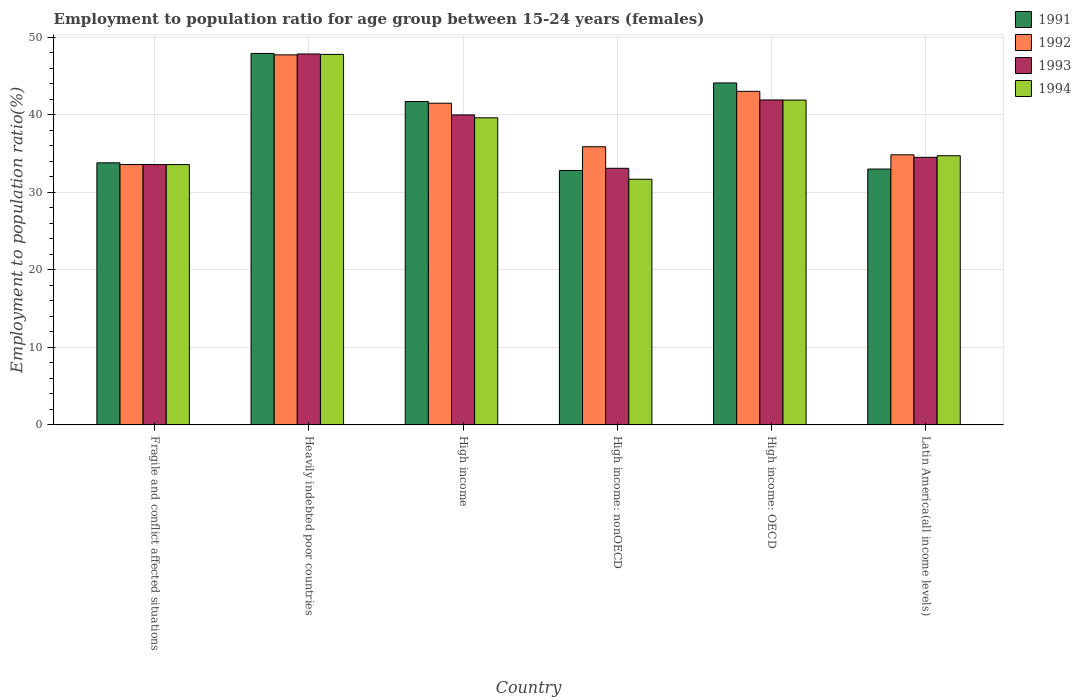How many different coloured bars are there?
Provide a succinct answer. 4. How many groups of bars are there?
Your answer should be very brief. 6. How many bars are there on the 5th tick from the left?
Ensure brevity in your answer.  4. What is the label of the 5th group of bars from the left?
Offer a terse response. High income: OECD. In how many cases, is the number of bars for a given country not equal to the number of legend labels?
Offer a very short reply. 0. What is the employment to population ratio in 1992 in High income: OECD?
Your answer should be very brief. 43.03. Across all countries, what is the maximum employment to population ratio in 1991?
Provide a succinct answer. 47.92. Across all countries, what is the minimum employment to population ratio in 1991?
Your response must be concise. 32.83. In which country was the employment to population ratio in 1993 maximum?
Provide a succinct answer. Heavily indebted poor countries. In which country was the employment to population ratio in 1991 minimum?
Keep it short and to the point. High income: nonOECD. What is the total employment to population ratio in 1994 in the graph?
Ensure brevity in your answer.  229.32. What is the difference between the employment to population ratio in 1991 in High income: OECD and that in High income: nonOECD?
Your answer should be very brief. 11.29. What is the difference between the employment to population ratio in 1992 in Latin America(all income levels) and the employment to population ratio in 1993 in High income: OECD?
Provide a succinct answer. -7.08. What is the average employment to population ratio in 1994 per country?
Keep it short and to the point. 38.22. What is the difference between the employment to population ratio of/in 1994 and employment to population ratio of/in 1993 in High income: OECD?
Provide a succinct answer. -0.02. In how many countries, is the employment to population ratio in 1991 greater than 46 %?
Your answer should be compact. 1. What is the ratio of the employment to population ratio in 1992 in Heavily indebted poor countries to that in High income?
Offer a terse response. 1.15. What is the difference between the highest and the second highest employment to population ratio in 1993?
Ensure brevity in your answer.  1.93. What is the difference between the highest and the lowest employment to population ratio in 1993?
Provide a short and direct response. 14.75. In how many countries, is the employment to population ratio in 1994 greater than the average employment to population ratio in 1994 taken over all countries?
Provide a succinct answer. 3. Is the sum of the employment to population ratio in 1993 in High income and High income: OECD greater than the maximum employment to population ratio in 1992 across all countries?
Give a very brief answer. Yes. Is it the case that in every country, the sum of the employment to population ratio in 1992 and employment to population ratio in 1994 is greater than the sum of employment to population ratio in 1993 and employment to population ratio in 1991?
Keep it short and to the point. No. What does the 3rd bar from the left in High income represents?
Keep it short and to the point. 1993. What does the 2nd bar from the right in Fragile and conflict affected situations represents?
Give a very brief answer. 1993. How many bars are there?
Give a very brief answer. 24. What is the difference between two consecutive major ticks on the Y-axis?
Your answer should be compact. 10. Does the graph contain grids?
Keep it short and to the point. Yes. What is the title of the graph?
Ensure brevity in your answer.  Employment to population ratio for age group between 15-24 years (females). Does "1981" appear as one of the legend labels in the graph?
Provide a succinct answer. No. What is the label or title of the X-axis?
Keep it short and to the point. Country. What is the label or title of the Y-axis?
Your answer should be compact. Employment to population ratio(%). What is the Employment to population ratio(%) of 1991 in Fragile and conflict affected situations?
Provide a short and direct response. 33.81. What is the Employment to population ratio(%) in 1992 in Fragile and conflict affected situations?
Your answer should be very brief. 33.59. What is the Employment to population ratio(%) in 1993 in Fragile and conflict affected situations?
Offer a terse response. 33.59. What is the Employment to population ratio(%) in 1994 in Fragile and conflict affected situations?
Make the answer very short. 33.59. What is the Employment to population ratio(%) in 1991 in Heavily indebted poor countries?
Your answer should be compact. 47.92. What is the Employment to population ratio(%) of 1992 in Heavily indebted poor countries?
Your response must be concise. 47.74. What is the Employment to population ratio(%) of 1993 in Heavily indebted poor countries?
Offer a terse response. 47.85. What is the Employment to population ratio(%) in 1994 in Heavily indebted poor countries?
Make the answer very short. 47.8. What is the Employment to population ratio(%) in 1991 in High income?
Provide a succinct answer. 41.72. What is the Employment to population ratio(%) in 1992 in High income?
Your response must be concise. 41.5. What is the Employment to population ratio(%) of 1993 in High income?
Provide a short and direct response. 39.99. What is the Employment to population ratio(%) in 1994 in High income?
Make the answer very short. 39.62. What is the Employment to population ratio(%) of 1991 in High income: nonOECD?
Your response must be concise. 32.83. What is the Employment to population ratio(%) of 1992 in High income: nonOECD?
Your answer should be very brief. 35.89. What is the Employment to population ratio(%) in 1993 in High income: nonOECD?
Provide a succinct answer. 33.1. What is the Employment to population ratio(%) in 1994 in High income: nonOECD?
Make the answer very short. 31.69. What is the Employment to population ratio(%) in 1991 in High income: OECD?
Make the answer very short. 44.12. What is the Employment to population ratio(%) in 1992 in High income: OECD?
Provide a succinct answer. 43.03. What is the Employment to population ratio(%) of 1993 in High income: OECD?
Your answer should be compact. 41.92. What is the Employment to population ratio(%) of 1994 in High income: OECD?
Offer a very short reply. 41.9. What is the Employment to population ratio(%) in 1991 in Latin America(all income levels)?
Keep it short and to the point. 33.01. What is the Employment to population ratio(%) in 1992 in Latin America(all income levels)?
Give a very brief answer. 34.84. What is the Employment to population ratio(%) of 1993 in Latin America(all income levels)?
Your answer should be very brief. 34.52. What is the Employment to population ratio(%) in 1994 in Latin America(all income levels)?
Your response must be concise. 34.73. Across all countries, what is the maximum Employment to population ratio(%) in 1991?
Provide a short and direct response. 47.92. Across all countries, what is the maximum Employment to population ratio(%) in 1992?
Provide a succinct answer. 47.74. Across all countries, what is the maximum Employment to population ratio(%) in 1993?
Make the answer very short. 47.85. Across all countries, what is the maximum Employment to population ratio(%) in 1994?
Your answer should be very brief. 47.8. Across all countries, what is the minimum Employment to population ratio(%) of 1991?
Your answer should be compact. 32.83. Across all countries, what is the minimum Employment to population ratio(%) in 1992?
Keep it short and to the point. 33.59. Across all countries, what is the minimum Employment to population ratio(%) of 1993?
Your response must be concise. 33.1. Across all countries, what is the minimum Employment to population ratio(%) in 1994?
Provide a short and direct response. 31.69. What is the total Employment to population ratio(%) in 1991 in the graph?
Offer a terse response. 233.39. What is the total Employment to population ratio(%) of 1992 in the graph?
Keep it short and to the point. 236.59. What is the total Employment to population ratio(%) in 1993 in the graph?
Make the answer very short. 230.97. What is the total Employment to population ratio(%) in 1994 in the graph?
Your answer should be very brief. 229.32. What is the difference between the Employment to population ratio(%) of 1991 in Fragile and conflict affected situations and that in Heavily indebted poor countries?
Provide a short and direct response. -14.11. What is the difference between the Employment to population ratio(%) of 1992 in Fragile and conflict affected situations and that in Heavily indebted poor countries?
Your answer should be very brief. -14.15. What is the difference between the Employment to population ratio(%) in 1993 in Fragile and conflict affected situations and that in Heavily indebted poor countries?
Provide a short and direct response. -14.26. What is the difference between the Employment to population ratio(%) in 1994 in Fragile and conflict affected situations and that in Heavily indebted poor countries?
Provide a short and direct response. -14.21. What is the difference between the Employment to population ratio(%) in 1991 in Fragile and conflict affected situations and that in High income?
Offer a very short reply. -7.91. What is the difference between the Employment to population ratio(%) in 1992 in Fragile and conflict affected situations and that in High income?
Keep it short and to the point. -7.91. What is the difference between the Employment to population ratio(%) in 1993 in Fragile and conflict affected situations and that in High income?
Your answer should be compact. -6.4. What is the difference between the Employment to population ratio(%) of 1994 in Fragile and conflict affected situations and that in High income?
Your answer should be compact. -6.03. What is the difference between the Employment to population ratio(%) in 1991 in Fragile and conflict affected situations and that in High income: nonOECD?
Provide a succinct answer. 0.98. What is the difference between the Employment to population ratio(%) in 1992 in Fragile and conflict affected situations and that in High income: nonOECD?
Give a very brief answer. -2.3. What is the difference between the Employment to population ratio(%) in 1993 in Fragile and conflict affected situations and that in High income: nonOECD?
Provide a short and direct response. 0.48. What is the difference between the Employment to population ratio(%) in 1994 in Fragile and conflict affected situations and that in High income: nonOECD?
Your answer should be compact. 1.89. What is the difference between the Employment to population ratio(%) in 1991 in Fragile and conflict affected situations and that in High income: OECD?
Offer a very short reply. -10.31. What is the difference between the Employment to population ratio(%) in 1992 in Fragile and conflict affected situations and that in High income: OECD?
Give a very brief answer. -9.44. What is the difference between the Employment to population ratio(%) of 1993 in Fragile and conflict affected situations and that in High income: OECD?
Your response must be concise. -8.33. What is the difference between the Employment to population ratio(%) of 1994 in Fragile and conflict affected situations and that in High income: OECD?
Offer a very short reply. -8.32. What is the difference between the Employment to population ratio(%) in 1991 in Fragile and conflict affected situations and that in Latin America(all income levels)?
Offer a terse response. 0.8. What is the difference between the Employment to population ratio(%) in 1992 in Fragile and conflict affected situations and that in Latin America(all income levels)?
Offer a terse response. -1.25. What is the difference between the Employment to population ratio(%) of 1993 in Fragile and conflict affected situations and that in Latin America(all income levels)?
Offer a very short reply. -0.93. What is the difference between the Employment to population ratio(%) in 1994 in Fragile and conflict affected situations and that in Latin America(all income levels)?
Your answer should be compact. -1.14. What is the difference between the Employment to population ratio(%) in 1991 in Heavily indebted poor countries and that in High income?
Provide a short and direct response. 6.2. What is the difference between the Employment to population ratio(%) of 1992 in Heavily indebted poor countries and that in High income?
Your response must be concise. 6.24. What is the difference between the Employment to population ratio(%) of 1993 in Heavily indebted poor countries and that in High income?
Keep it short and to the point. 7.86. What is the difference between the Employment to population ratio(%) in 1994 in Heavily indebted poor countries and that in High income?
Offer a terse response. 8.18. What is the difference between the Employment to population ratio(%) in 1991 in Heavily indebted poor countries and that in High income: nonOECD?
Your response must be concise. 15.1. What is the difference between the Employment to population ratio(%) in 1992 in Heavily indebted poor countries and that in High income: nonOECD?
Provide a short and direct response. 11.85. What is the difference between the Employment to population ratio(%) of 1993 in Heavily indebted poor countries and that in High income: nonOECD?
Make the answer very short. 14.75. What is the difference between the Employment to population ratio(%) in 1994 in Heavily indebted poor countries and that in High income: nonOECD?
Provide a short and direct response. 16.1. What is the difference between the Employment to population ratio(%) of 1991 in Heavily indebted poor countries and that in High income: OECD?
Keep it short and to the point. 3.8. What is the difference between the Employment to population ratio(%) in 1992 in Heavily indebted poor countries and that in High income: OECD?
Keep it short and to the point. 4.71. What is the difference between the Employment to population ratio(%) in 1993 in Heavily indebted poor countries and that in High income: OECD?
Your response must be concise. 5.93. What is the difference between the Employment to population ratio(%) of 1994 in Heavily indebted poor countries and that in High income: OECD?
Give a very brief answer. 5.89. What is the difference between the Employment to population ratio(%) in 1991 in Heavily indebted poor countries and that in Latin America(all income levels)?
Keep it short and to the point. 14.91. What is the difference between the Employment to population ratio(%) in 1992 in Heavily indebted poor countries and that in Latin America(all income levels)?
Your answer should be compact. 12.9. What is the difference between the Employment to population ratio(%) of 1993 in Heavily indebted poor countries and that in Latin America(all income levels)?
Keep it short and to the point. 13.33. What is the difference between the Employment to population ratio(%) in 1994 in Heavily indebted poor countries and that in Latin America(all income levels)?
Make the answer very short. 13.07. What is the difference between the Employment to population ratio(%) in 1991 in High income and that in High income: nonOECD?
Provide a short and direct response. 8.89. What is the difference between the Employment to population ratio(%) in 1992 in High income and that in High income: nonOECD?
Provide a short and direct response. 5.61. What is the difference between the Employment to population ratio(%) of 1993 in High income and that in High income: nonOECD?
Offer a very short reply. 6.89. What is the difference between the Employment to population ratio(%) in 1994 in High income and that in High income: nonOECD?
Your answer should be compact. 7.92. What is the difference between the Employment to population ratio(%) in 1991 in High income and that in High income: OECD?
Provide a short and direct response. -2.4. What is the difference between the Employment to population ratio(%) in 1992 in High income and that in High income: OECD?
Your answer should be very brief. -1.53. What is the difference between the Employment to population ratio(%) in 1993 in High income and that in High income: OECD?
Ensure brevity in your answer.  -1.93. What is the difference between the Employment to population ratio(%) in 1994 in High income and that in High income: OECD?
Provide a succinct answer. -2.28. What is the difference between the Employment to population ratio(%) of 1991 in High income and that in Latin America(all income levels)?
Provide a short and direct response. 8.71. What is the difference between the Employment to population ratio(%) in 1992 in High income and that in Latin America(all income levels)?
Give a very brief answer. 6.66. What is the difference between the Employment to population ratio(%) in 1993 in High income and that in Latin America(all income levels)?
Keep it short and to the point. 5.47. What is the difference between the Employment to population ratio(%) in 1994 in High income and that in Latin America(all income levels)?
Offer a terse response. 4.89. What is the difference between the Employment to population ratio(%) of 1991 in High income: nonOECD and that in High income: OECD?
Offer a very short reply. -11.29. What is the difference between the Employment to population ratio(%) in 1992 in High income: nonOECD and that in High income: OECD?
Offer a very short reply. -7.15. What is the difference between the Employment to population ratio(%) in 1993 in High income: nonOECD and that in High income: OECD?
Your answer should be compact. -8.82. What is the difference between the Employment to population ratio(%) of 1994 in High income: nonOECD and that in High income: OECD?
Provide a succinct answer. -10.21. What is the difference between the Employment to population ratio(%) of 1991 in High income: nonOECD and that in Latin America(all income levels)?
Offer a terse response. -0.18. What is the difference between the Employment to population ratio(%) in 1992 in High income: nonOECD and that in Latin America(all income levels)?
Provide a succinct answer. 1.04. What is the difference between the Employment to population ratio(%) of 1993 in High income: nonOECD and that in Latin America(all income levels)?
Provide a succinct answer. -1.42. What is the difference between the Employment to population ratio(%) in 1994 in High income: nonOECD and that in Latin America(all income levels)?
Offer a very short reply. -3.03. What is the difference between the Employment to population ratio(%) of 1991 in High income: OECD and that in Latin America(all income levels)?
Keep it short and to the point. 11.11. What is the difference between the Employment to population ratio(%) in 1992 in High income: OECD and that in Latin America(all income levels)?
Ensure brevity in your answer.  8.19. What is the difference between the Employment to population ratio(%) in 1993 in High income: OECD and that in Latin America(all income levels)?
Your response must be concise. 7.4. What is the difference between the Employment to population ratio(%) of 1994 in High income: OECD and that in Latin America(all income levels)?
Your response must be concise. 7.18. What is the difference between the Employment to population ratio(%) in 1991 in Fragile and conflict affected situations and the Employment to population ratio(%) in 1992 in Heavily indebted poor countries?
Make the answer very short. -13.93. What is the difference between the Employment to population ratio(%) of 1991 in Fragile and conflict affected situations and the Employment to population ratio(%) of 1993 in Heavily indebted poor countries?
Offer a terse response. -14.04. What is the difference between the Employment to population ratio(%) in 1991 in Fragile and conflict affected situations and the Employment to population ratio(%) in 1994 in Heavily indebted poor countries?
Ensure brevity in your answer.  -13.99. What is the difference between the Employment to population ratio(%) of 1992 in Fragile and conflict affected situations and the Employment to population ratio(%) of 1993 in Heavily indebted poor countries?
Your answer should be compact. -14.26. What is the difference between the Employment to population ratio(%) in 1992 in Fragile and conflict affected situations and the Employment to population ratio(%) in 1994 in Heavily indebted poor countries?
Provide a short and direct response. -14.21. What is the difference between the Employment to population ratio(%) of 1993 in Fragile and conflict affected situations and the Employment to population ratio(%) of 1994 in Heavily indebted poor countries?
Provide a short and direct response. -14.21. What is the difference between the Employment to population ratio(%) in 1991 in Fragile and conflict affected situations and the Employment to population ratio(%) in 1992 in High income?
Provide a succinct answer. -7.69. What is the difference between the Employment to population ratio(%) in 1991 in Fragile and conflict affected situations and the Employment to population ratio(%) in 1993 in High income?
Keep it short and to the point. -6.18. What is the difference between the Employment to population ratio(%) in 1991 in Fragile and conflict affected situations and the Employment to population ratio(%) in 1994 in High income?
Provide a succinct answer. -5.81. What is the difference between the Employment to population ratio(%) of 1992 in Fragile and conflict affected situations and the Employment to population ratio(%) of 1993 in High income?
Your answer should be compact. -6.4. What is the difference between the Employment to population ratio(%) of 1992 in Fragile and conflict affected situations and the Employment to population ratio(%) of 1994 in High income?
Offer a terse response. -6.03. What is the difference between the Employment to population ratio(%) in 1993 in Fragile and conflict affected situations and the Employment to population ratio(%) in 1994 in High income?
Keep it short and to the point. -6.03. What is the difference between the Employment to population ratio(%) of 1991 in Fragile and conflict affected situations and the Employment to population ratio(%) of 1992 in High income: nonOECD?
Offer a terse response. -2.08. What is the difference between the Employment to population ratio(%) in 1991 in Fragile and conflict affected situations and the Employment to population ratio(%) in 1993 in High income: nonOECD?
Offer a terse response. 0.71. What is the difference between the Employment to population ratio(%) of 1991 in Fragile and conflict affected situations and the Employment to population ratio(%) of 1994 in High income: nonOECD?
Provide a short and direct response. 2.12. What is the difference between the Employment to population ratio(%) of 1992 in Fragile and conflict affected situations and the Employment to population ratio(%) of 1993 in High income: nonOECD?
Offer a terse response. 0.49. What is the difference between the Employment to population ratio(%) of 1992 in Fragile and conflict affected situations and the Employment to population ratio(%) of 1994 in High income: nonOECD?
Your answer should be compact. 1.9. What is the difference between the Employment to population ratio(%) in 1993 in Fragile and conflict affected situations and the Employment to population ratio(%) in 1994 in High income: nonOECD?
Ensure brevity in your answer.  1.89. What is the difference between the Employment to population ratio(%) in 1991 in Fragile and conflict affected situations and the Employment to population ratio(%) in 1992 in High income: OECD?
Give a very brief answer. -9.22. What is the difference between the Employment to population ratio(%) in 1991 in Fragile and conflict affected situations and the Employment to population ratio(%) in 1993 in High income: OECD?
Keep it short and to the point. -8.11. What is the difference between the Employment to population ratio(%) of 1991 in Fragile and conflict affected situations and the Employment to population ratio(%) of 1994 in High income: OECD?
Give a very brief answer. -8.09. What is the difference between the Employment to population ratio(%) of 1992 in Fragile and conflict affected situations and the Employment to population ratio(%) of 1993 in High income: OECD?
Give a very brief answer. -8.33. What is the difference between the Employment to population ratio(%) in 1992 in Fragile and conflict affected situations and the Employment to population ratio(%) in 1994 in High income: OECD?
Offer a terse response. -8.31. What is the difference between the Employment to population ratio(%) of 1993 in Fragile and conflict affected situations and the Employment to population ratio(%) of 1994 in High income: OECD?
Make the answer very short. -8.31. What is the difference between the Employment to population ratio(%) of 1991 in Fragile and conflict affected situations and the Employment to population ratio(%) of 1992 in Latin America(all income levels)?
Offer a very short reply. -1.03. What is the difference between the Employment to population ratio(%) of 1991 in Fragile and conflict affected situations and the Employment to population ratio(%) of 1993 in Latin America(all income levels)?
Keep it short and to the point. -0.71. What is the difference between the Employment to population ratio(%) of 1991 in Fragile and conflict affected situations and the Employment to population ratio(%) of 1994 in Latin America(all income levels)?
Offer a very short reply. -0.92. What is the difference between the Employment to population ratio(%) of 1992 in Fragile and conflict affected situations and the Employment to population ratio(%) of 1993 in Latin America(all income levels)?
Provide a succinct answer. -0.93. What is the difference between the Employment to population ratio(%) of 1992 in Fragile and conflict affected situations and the Employment to population ratio(%) of 1994 in Latin America(all income levels)?
Provide a succinct answer. -1.14. What is the difference between the Employment to population ratio(%) of 1993 in Fragile and conflict affected situations and the Employment to population ratio(%) of 1994 in Latin America(all income levels)?
Your answer should be compact. -1.14. What is the difference between the Employment to population ratio(%) in 1991 in Heavily indebted poor countries and the Employment to population ratio(%) in 1992 in High income?
Keep it short and to the point. 6.42. What is the difference between the Employment to population ratio(%) in 1991 in Heavily indebted poor countries and the Employment to population ratio(%) in 1993 in High income?
Give a very brief answer. 7.93. What is the difference between the Employment to population ratio(%) of 1991 in Heavily indebted poor countries and the Employment to population ratio(%) of 1994 in High income?
Keep it short and to the point. 8.3. What is the difference between the Employment to population ratio(%) of 1992 in Heavily indebted poor countries and the Employment to population ratio(%) of 1993 in High income?
Offer a terse response. 7.75. What is the difference between the Employment to population ratio(%) of 1992 in Heavily indebted poor countries and the Employment to population ratio(%) of 1994 in High income?
Provide a succinct answer. 8.12. What is the difference between the Employment to population ratio(%) of 1993 in Heavily indebted poor countries and the Employment to population ratio(%) of 1994 in High income?
Your answer should be compact. 8.23. What is the difference between the Employment to population ratio(%) in 1991 in Heavily indebted poor countries and the Employment to population ratio(%) in 1992 in High income: nonOECD?
Keep it short and to the point. 12.03. What is the difference between the Employment to population ratio(%) in 1991 in Heavily indebted poor countries and the Employment to population ratio(%) in 1993 in High income: nonOECD?
Provide a short and direct response. 14.82. What is the difference between the Employment to population ratio(%) of 1991 in Heavily indebted poor countries and the Employment to population ratio(%) of 1994 in High income: nonOECD?
Offer a terse response. 16.23. What is the difference between the Employment to population ratio(%) in 1992 in Heavily indebted poor countries and the Employment to population ratio(%) in 1993 in High income: nonOECD?
Keep it short and to the point. 14.64. What is the difference between the Employment to population ratio(%) of 1992 in Heavily indebted poor countries and the Employment to population ratio(%) of 1994 in High income: nonOECD?
Your answer should be compact. 16.05. What is the difference between the Employment to population ratio(%) of 1993 in Heavily indebted poor countries and the Employment to population ratio(%) of 1994 in High income: nonOECD?
Keep it short and to the point. 16.16. What is the difference between the Employment to population ratio(%) of 1991 in Heavily indebted poor countries and the Employment to population ratio(%) of 1992 in High income: OECD?
Provide a short and direct response. 4.89. What is the difference between the Employment to population ratio(%) of 1991 in Heavily indebted poor countries and the Employment to population ratio(%) of 1993 in High income: OECD?
Your answer should be compact. 6. What is the difference between the Employment to population ratio(%) in 1991 in Heavily indebted poor countries and the Employment to population ratio(%) in 1994 in High income: OECD?
Your response must be concise. 6.02. What is the difference between the Employment to population ratio(%) of 1992 in Heavily indebted poor countries and the Employment to population ratio(%) of 1993 in High income: OECD?
Your answer should be compact. 5.82. What is the difference between the Employment to population ratio(%) of 1992 in Heavily indebted poor countries and the Employment to population ratio(%) of 1994 in High income: OECD?
Ensure brevity in your answer.  5.84. What is the difference between the Employment to population ratio(%) of 1993 in Heavily indebted poor countries and the Employment to population ratio(%) of 1994 in High income: OECD?
Ensure brevity in your answer.  5.95. What is the difference between the Employment to population ratio(%) of 1991 in Heavily indebted poor countries and the Employment to population ratio(%) of 1992 in Latin America(all income levels)?
Your answer should be compact. 13.08. What is the difference between the Employment to population ratio(%) of 1991 in Heavily indebted poor countries and the Employment to population ratio(%) of 1993 in Latin America(all income levels)?
Provide a short and direct response. 13.4. What is the difference between the Employment to population ratio(%) in 1991 in Heavily indebted poor countries and the Employment to population ratio(%) in 1994 in Latin America(all income levels)?
Your response must be concise. 13.19. What is the difference between the Employment to population ratio(%) in 1992 in Heavily indebted poor countries and the Employment to population ratio(%) in 1993 in Latin America(all income levels)?
Make the answer very short. 13.22. What is the difference between the Employment to population ratio(%) of 1992 in Heavily indebted poor countries and the Employment to population ratio(%) of 1994 in Latin America(all income levels)?
Give a very brief answer. 13.01. What is the difference between the Employment to population ratio(%) in 1993 in Heavily indebted poor countries and the Employment to population ratio(%) in 1994 in Latin America(all income levels)?
Give a very brief answer. 13.13. What is the difference between the Employment to population ratio(%) of 1991 in High income and the Employment to population ratio(%) of 1992 in High income: nonOECD?
Keep it short and to the point. 5.83. What is the difference between the Employment to population ratio(%) in 1991 in High income and the Employment to population ratio(%) in 1993 in High income: nonOECD?
Ensure brevity in your answer.  8.61. What is the difference between the Employment to population ratio(%) of 1991 in High income and the Employment to population ratio(%) of 1994 in High income: nonOECD?
Your answer should be very brief. 10.02. What is the difference between the Employment to population ratio(%) of 1992 in High income and the Employment to population ratio(%) of 1993 in High income: nonOECD?
Provide a short and direct response. 8.4. What is the difference between the Employment to population ratio(%) of 1992 in High income and the Employment to population ratio(%) of 1994 in High income: nonOECD?
Make the answer very short. 9.81. What is the difference between the Employment to population ratio(%) of 1993 in High income and the Employment to population ratio(%) of 1994 in High income: nonOECD?
Your answer should be very brief. 8.3. What is the difference between the Employment to population ratio(%) of 1991 in High income and the Employment to population ratio(%) of 1992 in High income: OECD?
Provide a short and direct response. -1.32. What is the difference between the Employment to population ratio(%) of 1991 in High income and the Employment to population ratio(%) of 1993 in High income: OECD?
Ensure brevity in your answer.  -0.21. What is the difference between the Employment to population ratio(%) of 1991 in High income and the Employment to population ratio(%) of 1994 in High income: OECD?
Your response must be concise. -0.19. What is the difference between the Employment to population ratio(%) of 1992 in High income and the Employment to population ratio(%) of 1993 in High income: OECD?
Provide a succinct answer. -0.42. What is the difference between the Employment to population ratio(%) of 1992 in High income and the Employment to population ratio(%) of 1994 in High income: OECD?
Your answer should be very brief. -0.4. What is the difference between the Employment to population ratio(%) in 1993 in High income and the Employment to population ratio(%) in 1994 in High income: OECD?
Provide a succinct answer. -1.91. What is the difference between the Employment to population ratio(%) of 1991 in High income and the Employment to population ratio(%) of 1992 in Latin America(all income levels)?
Make the answer very short. 6.87. What is the difference between the Employment to population ratio(%) in 1991 in High income and the Employment to population ratio(%) in 1993 in Latin America(all income levels)?
Ensure brevity in your answer.  7.2. What is the difference between the Employment to population ratio(%) in 1991 in High income and the Employment to population ratio(%) in 1994 in Latin America(all income levels)?
Ensure brevity in your answer.  6.99. What is the difference between the Employment to population ratio(%) in 1992 in High income and the Employment to population ratio(%) in 1993 in Latin America(all income levels)?
Your response must be concise. 6.98. What is the difference between the Employment to population ratio(%) of 1992 in High income and the Employment to population ratio(%) of 1994 in Latin America(all income levels)?
Ensure brevity in your answer.  6.77. What is the difference between the Employment to population ratio(%) in 1993 in High income and the Employment to population ratio(%) in 1994 in Latin America(all income levels)?
Provide a succinct answer. 5.26. What is the difference between the Employment to population ratio(%) of 1991 in High income: nonOECD and the Employment to population ratio(%) of 1992 in High income: OECD?
Provide a short and direct response. -10.21. What is the difference between the Employment to population ratio(%) in 1991 in High income: nonOECD and the Employment to population ratio(%) in 1993 in High income: OECD?
Give a very brief answer. -9.1. What is the difference between the Employment to population ratio(%) in 1991 in High income: nonOECD and the Employment to population ratio(%) in 1994 in High income: OECD?
Your answer should be compact. -9.08. What is the difference between the Employment to population ratio(%) of 1992 in High income: nonOECD and the Employment to population ratio(%) of 1993 in High income: OECD?
Ensure brevity in your answer.  -6.04. What is the difference between the Employment to population ratio(%) of 1992 in High income: nonOECD and the Employment to population ratio(%) of 1994 in High income: OECD?
Provide a succinct answer. -6.02. What is the difference between the Employment to population ratio(%) in 1993 in High income: nonOECD and the Employment to population ratio(%) in 1994 in High income: OECD?
Offer a very short reply. -8.8. What is the difference between the Employment to population ratio(%) in 1991 in High income: nonOECD and the Employment to population ratio(%) in 1992 in Latin America(all income levels)?
Offer a very short reply. -2.02. What is the difference between the Employment to population ratio(%) of 1991 in High income: nonOECD and the Employment to population ratio(%) of 1993 in Latin America(all income levels)?
Provide a short and direct response. -1.69. What is the difference between the Employment to population ratio(%) in 1991 in High income: nonOECD and the Employment to population ratio(%) in 1994 in Latin America(all income levels)?
Ensure brevity in your answer.  -1.9. What is the difference between the Employment to population ratio(%) of 1992 in High income: nonOECD and the Employment to population ratio(%) of 1993 in Latin America(all income levels)?
Offer a very short reply. 1.37. What is the difference between the Employment to population ratio(%) in 1992 in High income: nonOECD and the Employment to population ratio(%) in 1994 in Latin America(all income levels)?
Keep it short and to the point. 1.16. What is the difference between the Employment to population ratio(%) in 1993 in High income: nonOECD and the Employment to population ratio(%) in 1994 in Latin America(all income levels)?
Provide a succinct answer. -1.62. What is the difference between the Employment to population ratio(%) of 1991 in High income: OECD and the Employment to population ratio(%) of 1992 in Latin America(all income levels)?
Offer a very short reply. 9.27. What is the difference between the Employment to population ratio(%) in 1991 in High income: OECD and the Employment to population ratio(%) in 1993 in Latin America(all income levels)?
Make the answer very short. 9.6. What is the difference between the Employment to population ratio(%) of 1991 in High income: OECD and the Employment to population ratio(%) of 1994 in Latin America(all income levels)?
Ensure brevity in your answer.  9.39. What is the difference between the Employment to population ratio(%) of 1992 in High income: OECD and the Employment to population ratio(%) of 1993 in Latin America(all income levels)?
Offer a very short reply. 8.51. What is the difference between the Employment to population ratio(%) of 1992 in High income: OECD and the Employment to population ratio(%) of 1994 in Latin America(all income levels)?
Your response must be concise. 8.31. What is the difference between the Employment to population ratio(%) of 1993 in High income: OECD and the Employment to population ratio(%) of 1994 in Latin America(all income levels)?
Offer a terse response. 7.2. What is the average Employment to population ratio(%) in 1991 per country?
Ensure brevity in your answer.  38.9. What is the average Employment to population ratio(%) of 1992 per country?
Make the answer very short. 39.43. What is the average Employment to population ratio(%) in 1993 per country?
Give a very brief answer. 38.5. What is the average Employment to population ratio(%) in 1994 per country?
Keep it short and to the point. 38.22. What is the difference between the Employment to population ratio(%) of 1991 and Employment to population ratio(%) of 1992 in Fragile and conflict affected situations?
Your response must be concise. 0.22. What is the difference between the Employment to population ratio(%) of 1991 and Employment to population ratio(%) of 1993 in Fragile and conflict affected situations?
Keep it short and to the point. 0.22. What is the difference between the Employment to population ratio(%) of 1991 and Employment to population ratio(%) of 1994 in Fragile and conflict affected situations?
Keep it short and to the point. 0.22. What is the difference between the Employment to population ratio(%) of 1992 and Employment to population ratio(%) of 1993 in Fragile and conflict affected situations?
Your answer should be compact. 0. What is the difference between the Employment to population ratio(%) in 1992 and Employment to population ratio(%) in 1994 in Fragile and conflict affected situations?
Offer a terse response. 0.01. What is the difference between the Employment to population ratio(%) of 1993 and Employment to population ratio(%) of 1994 in Fragile and conflict affected situations?
Provide a succinct answer. 0. What is the difference between the Employment to population ratio(%) of 1991 and Employment to population ratio(%) of 1992 in Heavily indebted poor countries?
Your response must be concise. 0.18. What is the difference between the Employment to population ratio(%) in 1991 and Employment to population ratio(%) in 1993 in Heavily indebted poor countries?
Offer a terse response. 0.07. What is the difference between the Employment to population ratio(%) of 1991 and Employment to population ratio(%) of 1994 in Heavily indebted poor countries?
Your response must be concise. 0.12. What is the difference between the Employment to population ratio(%) of 1992 and Employment to population ratio(%) of 1993 in Heavily indebted poor countries?
Provide a succinct answer. -0.11. What is the difference between the Employment to population ratio(%) in 1992 and Employment to population ratio(%) in 1994 in Heavily indebted poor countries?
Provide a short and direct response. -0.06. What is the difference between the Employment to population ratio(%) of 1993 and Employment to population ratio(%) of 1994 in Heavily indebted poor countries?
Offer a very short reply. 0.05. What is the difference between the Employment to population ratio(%) of 1991 and Employment to population ratio(%) of 1992 in High income?
Keep it short and to the point. 0.22. What is the difference between the Employment to population ratio(%) in 1991 and Employment to population ratio(%) in 1993 in High income?
Offer a terse response. 1.72. What is the difference between the Employment to population ratio(%) of 1991 and Employment to population ratio(%) of 1994 in High income?
Give a very brief answer. 2.1. What is the difference between the Employment to population ratio(%) of 1992 and Employment to population ratio(%) of 1993 in High income?
Your answer should be very brief. 1.51. What is the difference between the Employment to population ratio(%) in 1992 and Employment to population ratio(%) in 1994 in High income?
Give a very brief answer. 1.88. What is the difference between the Employment to population ratio(%) of 1993 and Employment to population ratio(%) of 1994 in High income?
Give a very brief answer. 0.37. What is the difference between the Employment to population ratio(%) of 1991 and Employment to population ratio(%) of 1992 in High income: nonOECD?
Give a very brief answer. -3.06. What is the difference between the Employment to population ratio(%) of 1991 and Employment to population ratio(%) of 1993 in High income: nonOECD?
Give a very brief answer. -0.28. What is the difference between the Employment to population ratio(%) of 1991 and Employment to population ratio(%) of 1994 in High income: nonOECD?
Your response must be concise. 1.13. What is the difference between the Employment to population ratio(%) in 1992 and Employment to population ratio(%) in 1993 in High income: nonOECD?
Give a very brief answer. 2.78. What is the difference between the Employment to population ratio(%) in 1992 and Employment to population ratio(%) in 1994 in High income: nonOECD?
Offer a very short reply. 4.19. What is the difference between the Employment to population ratio(%) of 1993 and Employment to population ratio(%) of 1994 in High income: nonOECD?
Give a very brief answer. 1.41. What is the difference between the Employment to population ratio(%) of 1991 and Employment to population ratio(%) of 1992 in High income: OECD?
Make the answer very short. 1.08. What is the difference between the Employment to population ratio(%) of 1991 and Employment to population ratio(%) of 1993 in High income: OECD?
Your answer should be compact. 2.2. What is the difference between the Employment to population ratio(%) in 1991 and Employment to population ratio(%) in 1994 in High income: OECD?
Provide a succinct answer. 2.21. What is the difference between the Employment to population ratio(%) of 1992 and Employment to population ratio(%) of 1993 in High income: OECD?
Ensure brevity in your answer.  1.11. What is the difference between the Employment to population ratio(%) in 1992 and Employment to population ratio(%) in 1994 in High income: OECD?
Your response must be concise. 1.13. What is the difference between the Employment to population ratio(%) of 1993 and Employment to population ratio(%) of 1994 in High income: OECD?
Offer a very short reply. 0.02. What is the difference between the Employment to population ratio(%) in 1991 and Employment to population ratio(%) in 1992 in Latin America(all income levels)?
Provide a short and direct response. -1.84. What is the difference between the Employment to population ratio(%) in 1991 and Employment to population ratio(%) in 1993 in Latin America(all income levels)?
Make the answer very short. -1.51. What is the difference between the Employment to population ratio(%) in 1991 and Employment to population ratio(%) in 1994 in Latin America(all income levels)?
Your answer should be very brief. -1.72. What is the difference between the Employment to population ratio(%) in 1992 and Employment to population ratio(%) in 1993 in Latin America(all income levels)?
Provide a succinct answer. 0.32. What is the difference between the Employment to population ratio(%) in 1992 and Employment to population ratio(%) in 1994 in Latin America(all income levels)?
Your answer should be very brief. 0.12. What is the difference between the Employment to population ratio(%) of 1993 and Employment to population ratio(%) of 1994 in Latin America(all income levels)?
Offer a very short reply. -0.21. What is the ratio of the Employment to population ratio(%) in 1991 in Fragile and conflict affected situations to that in Heavily indebted poor countries?
Offer a terse response. 0.71. What is the ratio of the Employment to population ratio(%) in 1992 in Fragile and conflict affected situations to that in Heavily indebted poor countries?
Ensure brevity in your answer.  0.7. What is the ratio of the Employment to population ratio(%) of 1993 in Fragile and conflict affected situations to that in Heavily indebted poor countries?
Keep it short and to the point. 0.7. What is the ratio of the Employment to population ratio(%) in 1994 in Fragile and conflict affected situations to that in Heavily indebted poor countries?
Your response must be concise. 0.7. What is the ratio of the Employment to population ratio(%) of 1991 in Fragile and conflict affected situations to that in High income?
Your response must be concise. 0.81. What is the ratio of the Employment to population ratio(%) in 1992 in Fragile and conflict affected situations to that in High income?
Provide a succinct answer. 0.81. What is the ratio of the Employment to population ratio(%) in 1993 in Fragile and conflict affected situations to that in High income?
Give a very brief answer. 0.84. What is the ratio of the Employment to population ratio(%) of 1994 in Fragile and conflict affected situations to that in High income?
Make the answer very short. 0.85. What is the ratio of the Employment to population ratio(%) of 1992 in Fragile and conflict affected situations to that in High income: nonOECD?
Your response must be concise. 0.94. What is the ratio of the Employment to population ratio(%) of 1993 in Fragile and conflict affected situations to that in High income: nonOECD?
Give a very brief answer. 1.01. What is the ratio of the Employment to population ratio(%) in 1994 in Fragile and conflict affected situations to that in High income: nonOECD?
Your answer should be compact. 1.06. What is the ratio of the Employment to population ratio(%) in 1991 in Fragile and conflict affected situations to that in High income: OECD?
Offer a terse response. 0.77. What is the ratio of the Employment to population ratio(%) in 1992 in Fragile and conflict affected situations to that in High income: OECD?
Give a very brief answer. 0.78. What is the ratio of the Employment to population ratio(%) in 1993 in Fragile and conflict affected situations to that in High income: OECD?
Provide a succinct answer. 0.8. What is the ratio of the Employment to population ratio(%) of 1994 in Fragile and conflict affected situations to that in High income: OECD?
Keep it short and to the point. 0.8. What is the ratio of the Employment to population ratio(%) of 1991 in Fragile and conflict affected situations to that in Latin America(all income levels)?
Ensure brevity in your answer.  1.02. What is the ratio of the Employment to population ratio(%) of 1992 in Fragile and conflict affected situations to that in Latin America(all income levels)?
Your response must be concise. 0.96. What is the ratio of the Employment to population ratio(%) in 1994 in Fragile and conflict affected situations to that in Latin America(all income levels)?
Provide a succinct answer. 0.97. What is the ratio of the Employment to population ratio(%) of 1991 in Heavily indebted poor countries to that in High income?
Offer a very short reply. 1.15. What is the ratio of the Employment to population ratio(%) in 1992 in Heavily indebted poor countries to that in High income?
Ensure brevity in your answer.  1.15. What is the ratio of the Employment to population ratio(%) of 1993 in Heavily indebted poor countries to that in High income?
Give a very brief answer. 1.2. What is the ratio of the Employment to population ratio(%) of 1994 in Heavily indebted poor countries to that in High income?
Your response must be concise. 1.21. What is the ratio of the Employment to population ratio(%) in 1991 in Heavily indebted poor countries to that in High income: nonOECD?
Your answer should be compact. 1.46. What is the ratio of the Employment to population ratio(%) of 1992 in Heavily indebted poor countries to that in High income: nonOECD?
Ensure brevity in your answer.  1.33. What is the ratio of the Employment to population ratio(%) of 1993 in Heavily indebted poor countries to that in High income: nonOECD?
Give a very brief answer. 1.45. What is the ratio of the Employment to population ratio(%) of 1994 in Heavily indebted poor countries to that in High income: nonOECD?
Provide a succinct answer. 1.51. What is the ratio of the Employment to population ratio(%) of 1991 in Heavily indebted poor countries to that in High income: OECD?
Your answer should be compact. 1.09. What is the ratio of the Employment to population ratio(%) in 1992 in Heavily indebted poor countries to that in High income: OECD?
Offer a terse response. 1.11. What is the ratio of the Employment to population ratio(%) of 1993 in Heavily indebted poor countries to that in High income: OECD?
Ensure brevity in your answer.  1.14. What is the ratio of the Employment to population ratio(%) in 1994 in Heavily indebted poor countries to that in High income: OECD?
Your answer should be very brief. 1.14. What is the ratio of the Employment to population ratio(%) in 1991 in Heavily indebted poor countries to that in Latin America(all income levels)?
Provide a succinct answer. 1.45. What is the ratio of the Employment to population ratio(%) in 1992 in Heavily indebted poor countries to that in Latin America(all income levels)?
Make the answer very short. 1.37. What is the ratio of the Employment to population ratio(%) of 1993 in Heavily indebted poor countries to that in Latin America(all income levels)?
Offer a terse response. 1.39. What is the ratio of the Employment to population ratio(%) of 1994 in Heavily indebted poor countries to that in Latin America(all income levels)?
Your answer should be very brief. 1.38. What is the ratio of the Employment to population ratio(%) in 1991 in High income to that in High income: nonOECD?
Ensure brevity in your answer.  1.27. What is the ratio of the Employment to population ratio(%) in 1992 in High income to that in High income: nonOECD?
Provide a short and direct response. 1.16. What is the ratio of the Employment to population ratio(%) in 1993 in High income to that in High income: nonOECD?
Give a very brief answer. 1.21. What is the ratio of the Employment to population ratio(%) of 1991 in High income to that in High income: OECD?
Provide a succinct answer. 0.95. What is the ratio of the Employment to population ratio(%) of 1992 in High income to that in High income: OECD?
Give a very brief answer. 0.96. What is the ratio of the Employment to population ratio(%) in 1993 in High income to that in High income: OECD?
Offer a terse response. 0.95. What is the ratio of the Employment to population ratio(%) of 1994 in High income to that in High income: OECD?
Your answer should be compact. 0.95. What is the ratio of the Employment to population ratio(%) of 1991 in High income to that in Latin America(all income levels)?
Keep it short and to the point. 1.26. What is the ratio of the Employment to population ratio(%) of 1992 in High income to that in Latin America(all income levels)?
Provide a short and direct response. 1.19. What is the ratio of the Employment to population ratio(%) in 1993 in High income to that in Latin America(all income levels)?
Offer a very short reply. 1.16. What is the ratio of the Employment to population ratio(%) of 1994 in High income to that in Latin America(all income levels)?
Your answer should be very brief. 1.14. What is the ratio of the Employment to population ratio(%) in 1991 in High income: nonOECD to that in High income: OECD?
Make the answer very short. 0.74. What is the ratio of the Employment to population ratio(%) of 1992 in High income: nonOECD to that in High income: OECD?
Your response must be concise. 0.83. What is the ratio of the Employment to population ratio(%) in 1993 in High income: nonOECD to that in High income: OECD?
Provide a succinct answer. 0.79. What is the ratio of the Employment to population ratio(%) in 1994 in High income: nonOECD to that in High income: OECD?
Your answer should be very brief. 0.76. What is the ratio of the Employment to population ratio(%) in 1991 in High income: nonOECD to that in Latin America(all income levels)?
Provide a succinct answer. 0.99. What is the ratio of the Employment to population ratio(%) of 1992 in High income: nonOECD to that in Latin America(all income levels)?
Offer a very short reply. 1.03. What is the ratio of the Employment to population ratio(%) of 1993 in High income: nonOECD to that in Latin America(all income levels)?
Offer a very short reply. 0.96. What is the ratio of the Employment to population ratio(%) of 1994 in High income: nonOECD to that in Latin America(all income levels)?
Keep it short and to the point. 0.91. What is the ratio of the Employment to population ratio(%) of 1991 in High income: OECD to that in Latin America(all income levels)?
Your answer should be very brief. 1.34. What is the ratio of the Employment to population ratio(%) in 1992 in High income: OECD to that in Latin America(all income levels)?
Offer a very short reply. 1.24. What is the ratio of the Employment to population ratio(%) of 1993 in High income: OECD to that in Latin America(all income levels)?
Provide a succinct answer. 1.21. What is the ratio of the Employment to population ratio(%) in 1994 in High income: OECD to that in Latin America(all income levels)?
Keep it short and to the point. 1.21. What is the difference between the highest and the second highest Employment to population ratio(%) of 1991?
Your answer should be compact. 3.8. What is the difference between the highest and the second highest Employment to population ratio(%) in 1992?
Ensure brevity in your answer.  4.71. What is the difference between the highest and the second highest Employment to population ratio(%) in 1993?
Provide a succinct answer. 5.93. What is the difference between the highest and the second highest Employment to population ratio(%) in 1994?
Provide a short and direct response. 5.89. What is the difference between the highest and the lowest Employment to population ratio(%) in 1991?
Your answer should be compact. 15.1. What is the difference between the highest and the lowest Employment to population ratio(%) of 1992?
Provide a short and direct response. 14.15. What is the difference between the highest and the lowest Employment to population ratio(%) of 1993?
Your response must be concise. 14.75. What is the difference between the highest and the lowest Employment to population ratio(%) in 1994?
Your response must be concise. 16.1. 